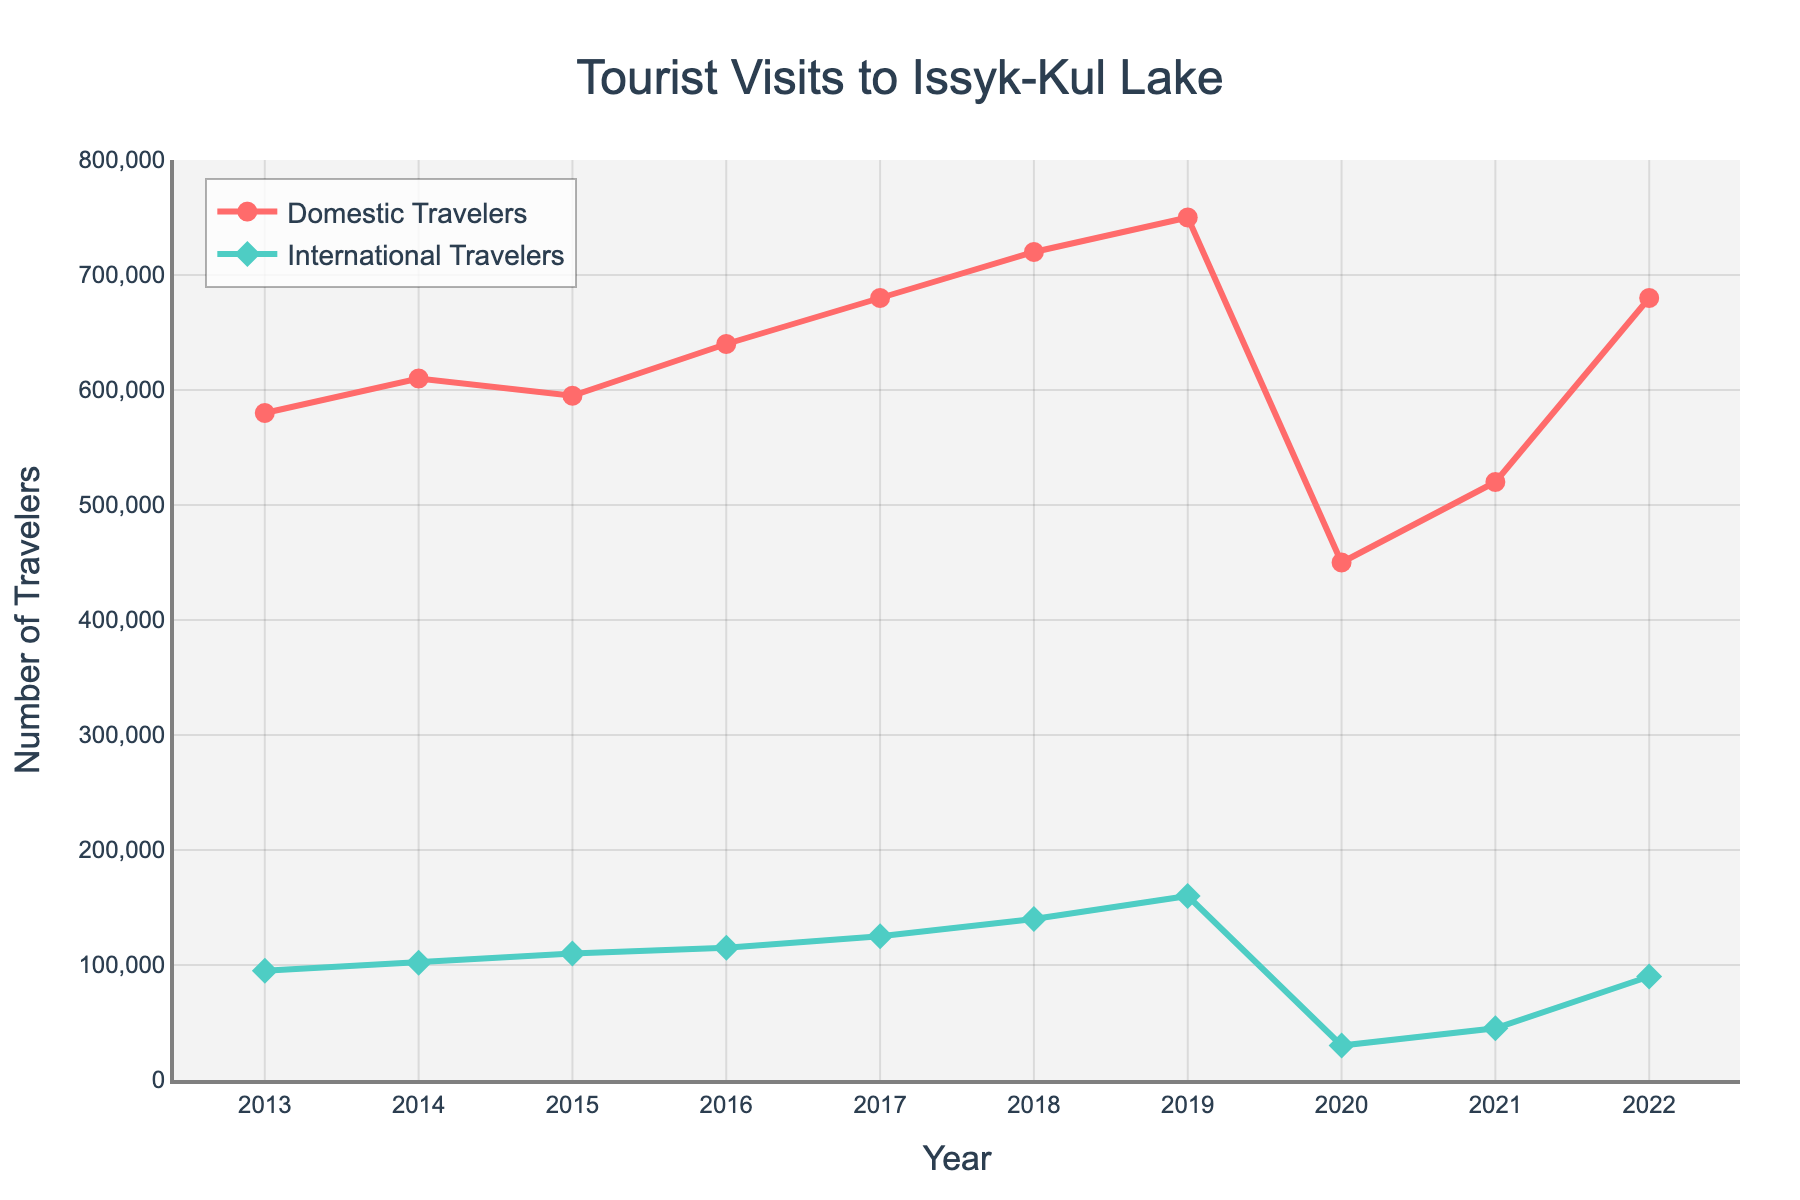What's the overall trend of domestic travelers from 2013 to 2022? The line representing domestic travelers generally shows an upward trend from 2013 to 2019, a significant dip in 2020 followed by a recovery from 2021 to 2022.
Answer: Upward with a dip in 2020 Which year saw the highest number of international travelers? By observing the peak of the line representing international travelers, the highest number of international travelers is seen in 2019.
Answer: 2019 How many more domestic travelers visited in 2016 compared to 2015? In 2015, there were 595,000 domestic travelers, and in 2016, there were 640,000. The difference is 640,000 - 595,000 = 45,000.
Answer: 45,000 Which year has the smallest gap between domestic and international travelers? The gap can be calculated for each year, and 2020 clearly shows the smallest difference when the visual gap between the lines is minimal.
Answer: 2020 What is the percentage increase in international travelers from 2013 to 2019? In 2013, there were 95,000 international travelers, and in 2019, there were 160,000. The percentage increase is ((160,000 - 95,000) / 95,000) * 100 = 68.42%.
Answer: 68.42% In which year(s) did both domestic and international travelers increase compared to the previous year? By observing the lines, both domestic and international travelers increased from the previous year in 2014, 2016, 2017, and 2018.
Answer: 2014, 2016, 2017, 2018 What's the total number of domestic travelers over the given period? Sum of domestic travelers from 2013 to 2022: 580,000 + 610,000 + 595,000 + 640,000 + 680,000 + 720,000 + 750,000 + 450,000 + 520,000 + 680,000 = 6,225,000.
Answer: 6,225,000 Compare the trend of international travelers before and after 2020. Before 2020, the trend of international travelers is generally increasing. After 2020, the number drops sharply and shows a smaller recovery in 2021 and 2022 compared to before.
Answer: Increasing before 2020, sharp drop and smaller recovery after 2020 What is the average number of domestic travelers from 2013 to 2019? Sum of domestic travelers from 2013 to 2019 is 4,575,000. The number of years is 7. The average is 4,575,000 / 7 = 653,571.
Answer: 653,571 During which period did the number of domestic travelers decrease? By examining the line for domestic travelers, the numbers decreased between 2014 and 2015 and then again from 2019 to 2020.
Answer: 2014-2015, 2019-2020 